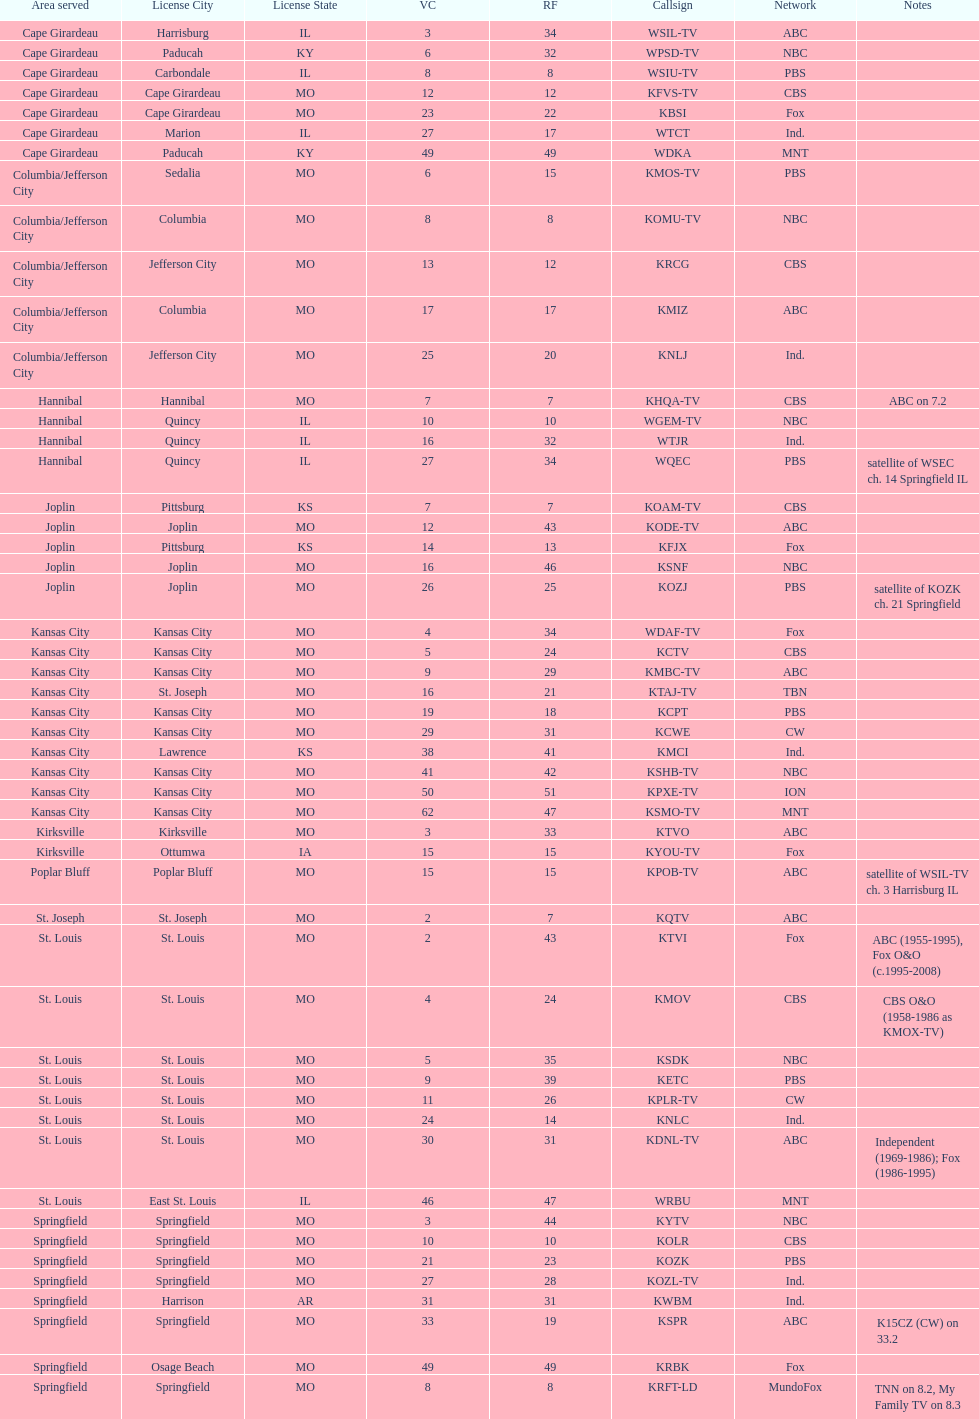Kode-tv and wsil-tv both are a part of which network? ABC. 